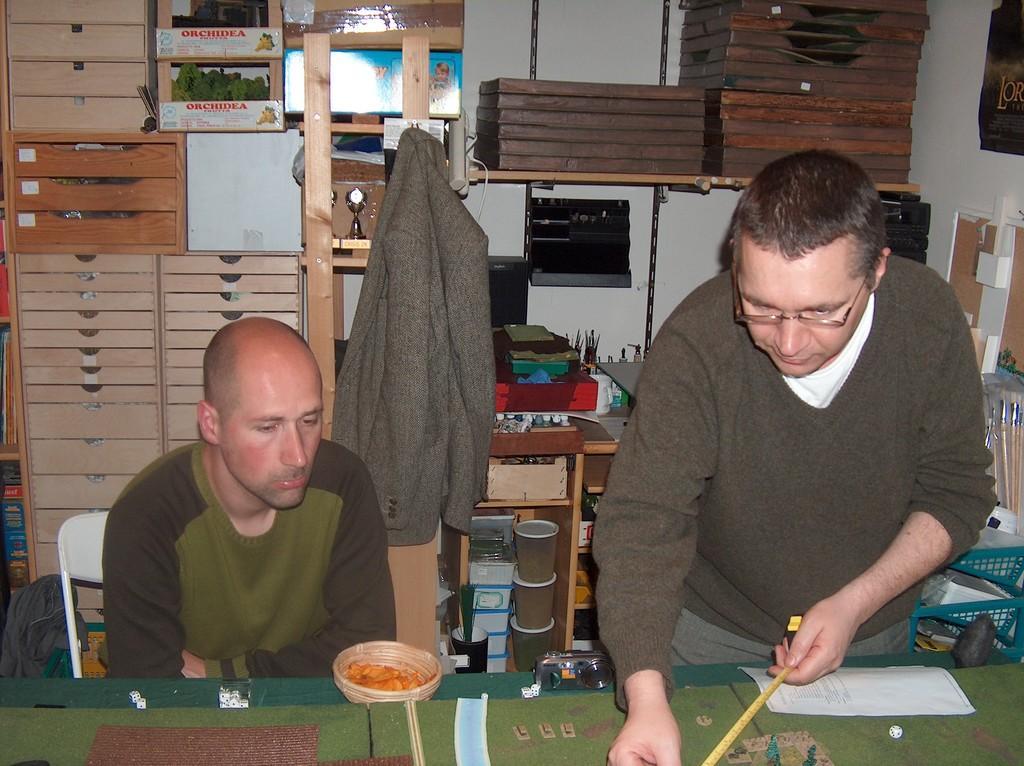How would you summarize this image in a sentence or two? In this image I can see two men where one is standing and one is sitting on a chair. In the background I can see a jacket and few glasses. 